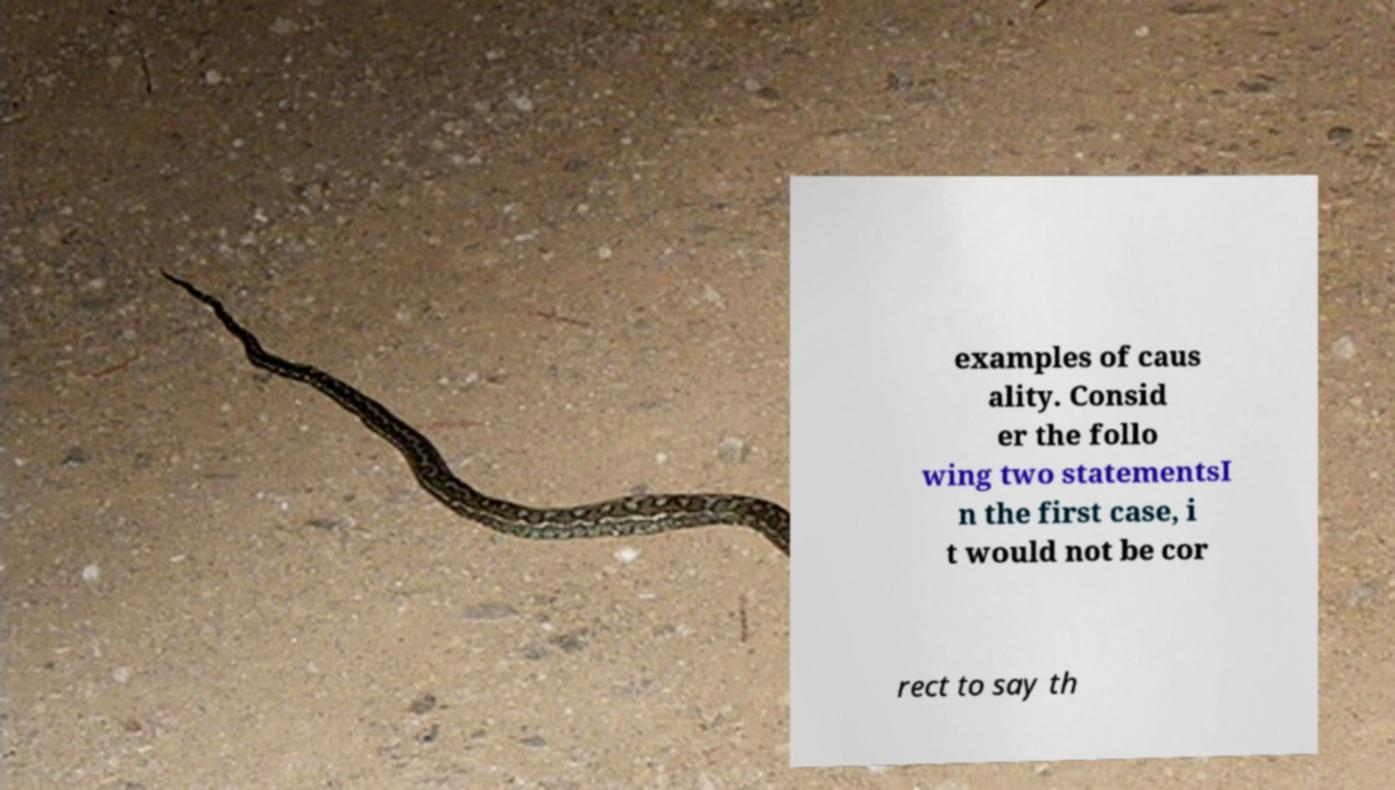Please read and relay the text visible in this image. What does it say? examples of caus ality. Consid er the follo wing two statementsI n the first case, i t would not be cor rect to say th 